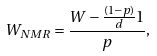<formula> <loc_0><loc_0><loc_500><loc_500>W _ { N M R } = \frac { W - \frac { ( 1 - p ) } { d } \mathbb { m } { 1 } } { p } ,</formula> 